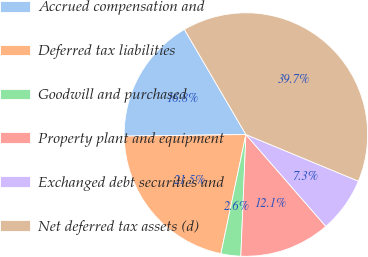Convert chart to OTSL. <chart><loc_0><loc_0><loc_500><loc_500><pie_chart><fcel>Accrued compensation and<fcel>Deferred tax liabilities<fcel>Goodwill and purchased<fcel>Property plant and equipment<fcel>Exchanged debt securities and<fcel>Net deferred tax assets (d)<nl><fcel>16.78%<fcel>21.5%<fcel>2.63%<fcel>12.06%<fcel>7.35%<fcel>39.68%<nl></chart> 